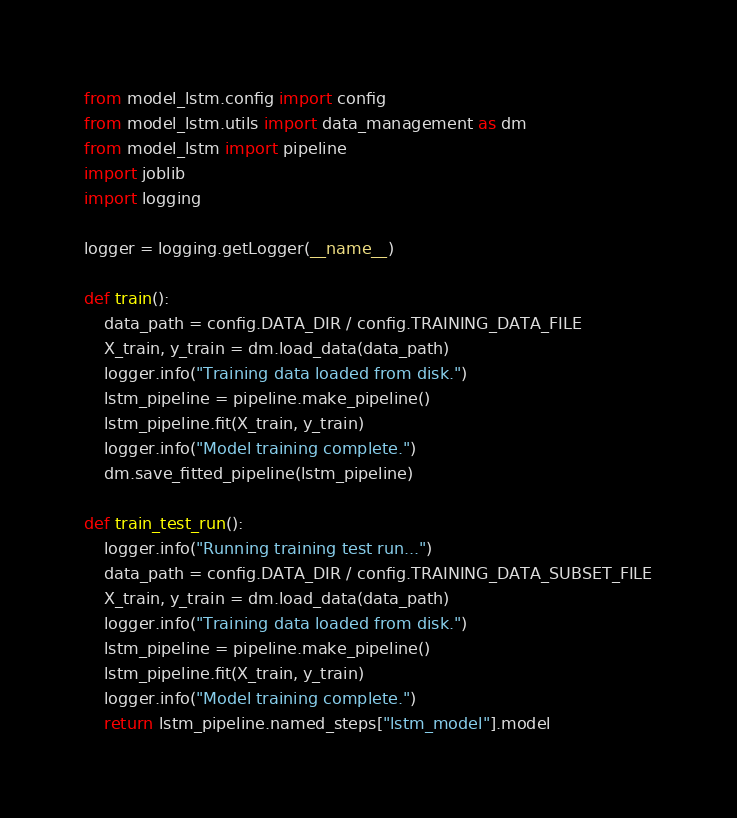<code> <loc_0><loc_0><loc_500><loc_500><_Python_>from model_lstm.config import config
from model_lstm.utils import data_management as dm
from model_lstm import pipeline
import joblib
import logging

logger = logging.getLogger(__name__)

def train():
    data_path = config.DATA_DIR / config.TRAINING_DATA_FILE
    X_train, y_train = dm.load_data(data_path)
    logger.info("Training data loaded from disk.")
    lstm_pipeline = pipeline.make_pipeline()
    lstm_pipeline.fit(X_train, y_train)
    logger.info("Model training complete.")
    dm.save_fitted_pipeline(lstm_pipeline)

def train_test_run():
    logger.info("Running training test run...")
    data_path = config.DATA_DIR / config.TRAINING_DATA_SUBSET_FILE
    X_train, y_train = dm.load_data(data_path)
    logger.info("Training data loaded from disk.")
    lstm_pipeline = pipeline.make_pipeline()
    lstm_pipeline.fit(X_train, y_train)
    logger.info("Model training complete.")
    return lstm_pipeline.named_steps["lstm_model"].model</code> 